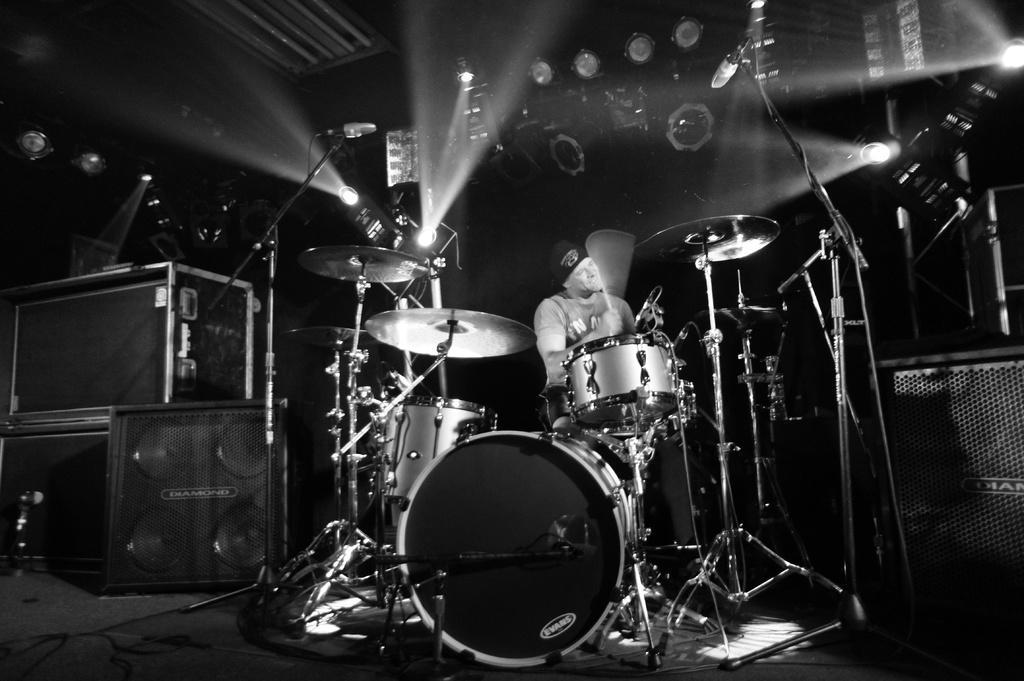Could you give a brief overview of what you see in this image? In the image in the center we can see one person standing and holding a guitar. In front of him,there is a monitor,speaker and musical instruments. In the background there is a roof,wall and lights. 